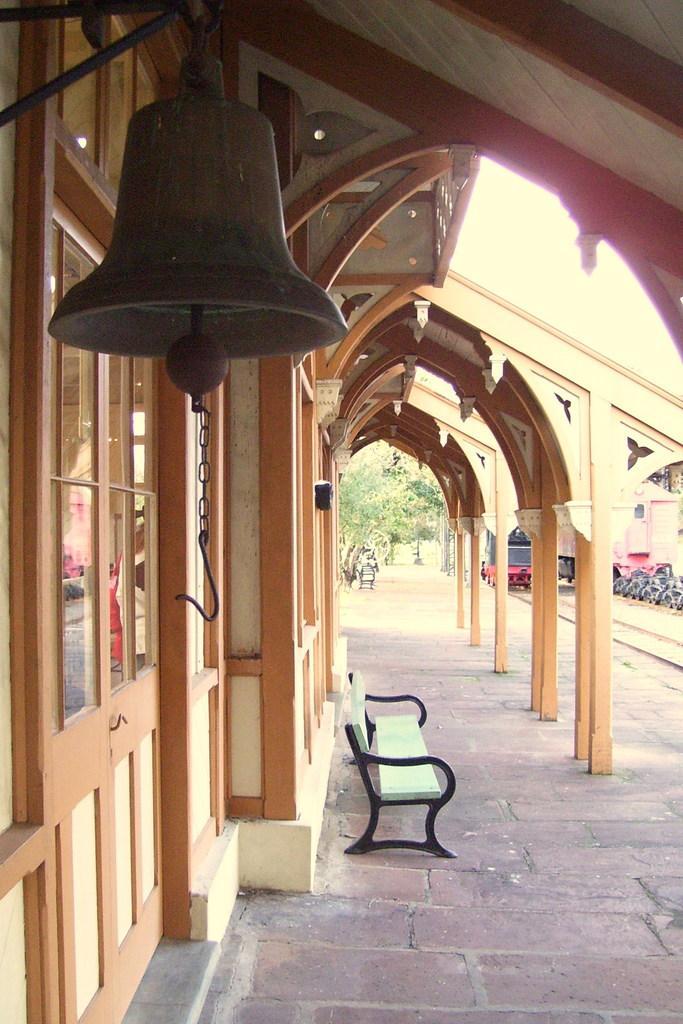Describe this image in one or two sentences. In this picture we can see a bell here, there is a bench here, we can see a porch here, on the left side there is a glass, in the background there are some trees. 